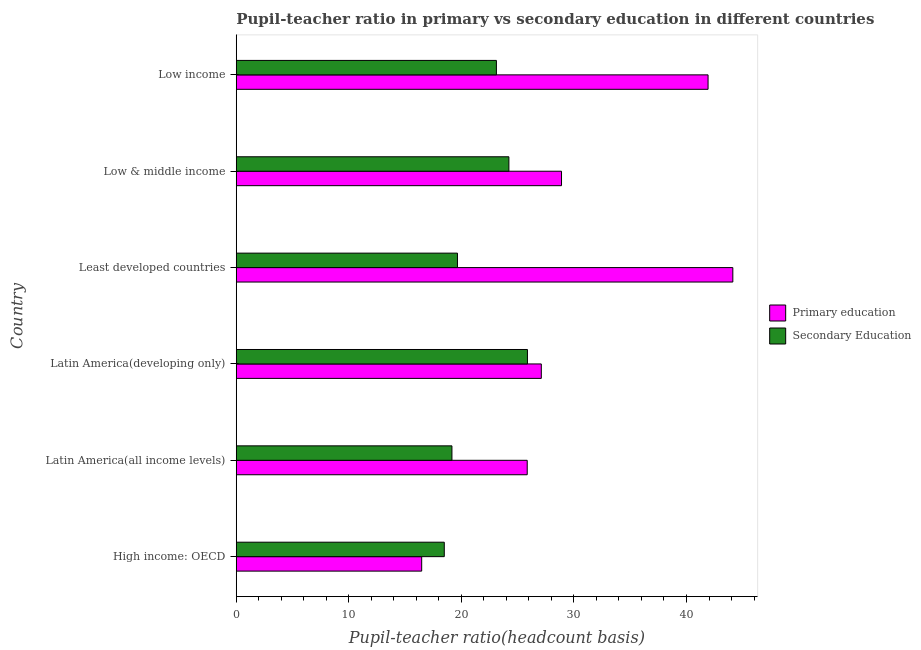How many different coloured bars are there?
Your answer should be very brief. 2. How many groups of bars are there?
Give a very brief answer. 6. Are the number of bars on each tick of the Y-axis equal?
Provide a short and direct response. Yes. How many bars are there on the 3rd tick from the top?
Keep it short and to the point. 2. What is the label of the 1st group of bars from the top?
Make the answer very short. Low income. What is the pupil teacher ratio on secondary education in Latin America(all income levels)?
Give a very brief answer. 19.16. Across all countries, what is the maximum pupil teacher ratio on secondary education?
Give a very brief answer. 25.87. Across all countries, what is the minimum pupil-teacher ratio in primary education?
Offer a very short reply. 16.47. In which country was the pupil teacher ratio on secondary education maximum?
Provide a succinct answer. Latin America(developing only). In which country was the pupil teacher ratio on secondary education minimum?
Provide a succinct answer. High income: OECD. What is the total pupil teacher ratio on secondary education in the graph?
Give a very brief answer. 130.5. What is the difference between the pupil teacher ratio on secondary education in Latin America(all income levels) and that in Low & middle income?
Your response must be concise. -5.06. What is the difference between the pupil teacher ratio on secondary education in High income: OECD and the pupil-teacher ratio in primary education in Low income?
Make the answer very short. -23.44. What is the average pupil-teacher ratio in primary education per country?
Provide a short and direct response. 30.73. What is the difference between the pupil-teacher ratio in primary education and pupil teacher ratio on secondary education in High income: OECD?
Offer a very short reply. -2.01. In how many countries, is the pupil teacher ratio on secondary education greater than 12 ?
Offer a terse response. 6. What is the ratio of the pupil teacher ratio on secondary education in Latin America(all income levels) to that in Low income?
Your answer should be very brief. 0.83. What is the difference between the highest and the second highest pupil teacher ratio on secondary education?
Give a very brief answer. 1.65. What is the difference between the highest and the lowest pupil-teacher ratio in primary education?
Ensure brevity in your answer.  27.64. How many bars are there?
Offer a very short reply. 12. What is the difference between two consecutive major ticks on the X-axis?
Ensure brevity in your answer.  10. Are the values on the major ticks of X-axis written in scientific E-notation?
Give a very brief answer. No. Does the graph contain any zero values?
Your answer should be compact. No. Where does the legend appear in the graph?
Provide a short and direct response. Center right. How are the legend labels stacked?
Give a very brief answer. Vertical. What is the title of the graph?
Provide a short and direct response. Pupil-teacher ratio in primary vs secondary education in different countries. Does "Official creditors" appear as one of the legend labels in the graph?
Your answer should be very brief. No. What is the label or title of the X-axis?
Keep it short and to the point. Pupil-teacher ratio(headcount basis). What is the label or title of the Y-axis?
Offer a very short reply. Country. What is the Pupil-teacher ratio(headcount basis) in Primary education in High income: OECD?
Ensure brevity in your answer.  16.47. What is the Pupil-teacher ratio(headcount basis) in Secondary Education in High income: OECD?
Your response must be concise. 18.48. What is the Pupil-teacher ratio(headcount basis) of Primary education in Latin America(all income levels)?
Your answer should be very brief. 25.85. What is the Pupil-teacher ratio(headcount basis) in Secondary Education in Latin America(all income levels)?
Provide a short and direct response. 19.16. What is the Pupil-teacher ratio(headcount basis) in Primary education in Latin America(developing only)?
Ensure brevity in your answer.  27.1. What is the Pupil-teacher ratio(headcount basis) of Secondary Education in Latin America(developing only)?
Your answer should be very brief. 25.87. What is the Pupil-teacher ratio(headcount basis) in Primary education in Least developed countries?
Your answer should be very brief. 44.12. What is the Pupil-teacher ratio(headcount basis) in Secondary Education in Least developed countries?
Your answer should be compact. 19.65. What is the Pupil-teacher ratio(headcount basis) of Primary education in Low & middle income?
Provide a succinct answer. 28.9. What is the Pupil-teacher ratio(headcount basis) of Secondary Education in Low & middle income?
Give a very brief answer. 24.22. What is the Pupil-teacher ratio(headcount basis) of Primary education in Low income?
Your response must be concise. 41.92. What is the Pupil-teacher ratio(headcount basis) of Secondary Education in Low income?
Offer a terse response. 23.11. Across all countries, what is the maximum Pupil-teacher ratio(headcount basis) in Primary education?
Give a very brief answer. 44.12. Across all countries, what is the maximum Pupil-teacher ratio(headcount basis) of Secondary Education?
Your answer should be very brief. 25.87. Across all countries, what is the minimum Pupil-teacher ratio(headcount basis) in Primary education?
Your answer should be very brief. 16.47. Across all countries, what is the minimum Pupil-teacher ratio(headcount basis) in Secondary Education?
Your response must be concise. 18.48. What is the total Pupil-teacher ratio(headcount basis) in Primary education in the graph?
Offer a terse response. 184.36. What is the total Pupil-teacher ratio(headcount basis) in Secondary Education in the graph?
Ensure brevity in your answer.  130.5. What is the difference between the Pupil-teacher ratio(headcount basis) in Primary education in High income: OECD and that in Latin America(all income levels)?
Give a very brief answer. -9.38. What is the difference between the Pupil-teacher ratio(headcount basis) of Secondary Education in High income: OECD and that in Latin America(all income levels)?
Offer a very short reply. -0.68. What is the difference between the Pupil-teacher ratio(headcount basis) of Primary education in High income: OECD and that in Latin America(developing only)?
Give a very brief answer. -10.63. What is the difference between the Pupil-teacher ratio(headcount basis) of Secondary Education in High income: OECD and that in Latin America(developing only)?
Offer a very short reply. -7.39. What is the difference between the Pupil-teacher ratio(headcount basis) of Primary education in High income: OECD and that in Least developed countries?
Your answer should be compact. -27.64. What is the difference between the Pupil-teacher ratio(headcount basis) in Secondary Education in High income: OECD and that in Least developed countries?
Give a very brief answer. -1.17. What is the difference between the Pupil-teacher ratio(headcount basis) in Primary education in High income: OECD and that in Low & middle income?
Offer a terse response. -12.42. What is the difference between the Pupil-teacher ratio(headcount basis) of Secondary Education in High income: OECD and that in Low & middle income?
Provide a short and direct response. -5.74. What is the difference between the Pupil-teacher ratio(headcount basis) in Primary education in High income: OECD and that in Low income?
Keep it short and to the point. -25.44. What is the difference between the Pupil-teacher ratio(headcount basis) of Secondary Education in High income: OECD and that in Low income?
Provide a short and direct response. -4.63. What is the difference between the Pupil-teacher ratio(headcount basis) in Primary education in Latin America(all income levels) and that in Latin America(developing only)?
Give a very brief answer. -1.25. What is the difference between the Pupil-teacher ratio(headcount basis) in Secondary Education in Latin America(all income levels) and that in Latin America(developing only)?
Your answer should be very brief. -6.71. What is the difference between the Pupil-teacher ratio(headcount basis) in Primary education in Latin America(all income levels) and that in Least developed countries?
Keep it short and to the point. -18.27. What is the difference between the Pupil-teacher ratio(headcount basis) in Secondary Education in Latin America(all income levels) and that in Least developed countries?
Make the answer very short. -0.49. What is the difference between the Pupil-teacher ratio(headcount basis) in Primary education in Latin America(all income levels) and that in Low & middle income?
Provide a succinct answer. -3.05. What is the difference between the Pupil-teacher ratio(headcount basis) of Secondary Education in Latin America(all income levels) and that in Low & middle income?
Offer a very short reply. -5.06. What is the difference between the Pupil-teacher ratio(headcount basis) in Primary education in Latin America(all income levels) and that in Low income?
Ensure brevity in your answer.  -16.07. What is the difference between the Pupil-teacher ratio(headcount basis) of Secondary Education in Latin America(all income levels) and that in Low income?
Give a very brief answer. -3.95. What is the difference between the Pupil-teacher ratio(headcount basis) in Primary education in Latin America(developing only) and that in Least developed countries?
Your answer should be compact. -17.02. What is the difference between the Pupil-teacher ratio(headcount basis) in Secondary Education in Latin America(developing only) and that in Least developed countries?
Provide a succinct answer. 6.22. What is the difference between the Pupil-teacher ratio(headcount basis) of Primary education in Latin America(developing only) and that in Low & middle income?
Offer a very short reply. -1.79. What is the difference between the Pupil-teacher ratio(headcount basis) of Secondary Education in Latin America(developing only) and that in Low & middle income?
Provide a succinct answer. 1.65. What is the difference between the Pupil-teacher ratio(headcount basis) in Primary education in Latin America(developing only) and that in Low income?
Your answer should be very brief. -14.81. What is the difference between the Pupil-teacher ratio(headcount basis) in Secondary Education in Latin America(developing only) and that in Low income?
Your response must be concise. 2.76. What is the difference between the Pupil-teacher ratio(headcount basis) in Primary education in Least developed countries and that in Low & middle income?
Make the answer very short. 15.22. What is the difference between the Pupil-teacher ratio(headcount basis) in Secondary Education in Least developed countries and that in Low & middle income?
Your response must be concise. -4.57. What is the difference between the Pupil-teacher ratio(headcount basis) in Primary education in Least developed countries and that in Low income?
Ensure brevity in your answer.  2.2. What is the difference between the Pupil-teacher ratio(headcount basis) in Secondary Education in Least developed countries and that in Low income?
Offer a terse response. -3.46. What is the difference between the Pupil-teacher ratio(headcount basis) of Primary education in Low & middle income and that in Low income?
Provide a succinct answer. -13.02. What is the difference between the Pupil-teacher ratio(headcount basis) in Secondary Education in Low & middle income and that in Low income?
Make the answer very short. 1.11. What is the difference between the Pupil-teacher ratio(headcount basis) in Primary education in High income: OECD and the Pupil-teacher ratio(headcount basis) in Secondary Education in Latin America(all income levels)?
Your answer should be compact. -2.69. What is the difference between the Pupil-teacher ratio(headcount basis) of Primary education in High income: OECD and the Pupil-teacher ratio(headcount basis) of Secondary Education in Latin America(developing only)?
Give a very brief answer. -9.4. What is the difference between the Pupil-teacher ratio(headcount basis) of Primary education in High income: OECD and the Pupil-teacher ratio(headcount basis) of Secondary Education in Least developed countries?
Make the answer very short. -3.18. What is the difference between the Pupil-teacher ratio(headcount basis) of Primary education in High income: OECD and the Pupil-teacher ratio(headcount basis) of Secondary Education in Low & middle income?
Your response must be concise. -7.75. What is the difference between the Pupil-teacher ratio(headcount basis) in Primary education in High income: OECD and the Pupil-teacher ratio(headcount basis) in Secondary Education in Low income?
Keep it short and to the point. -6.64. What is the difference between the Pupil-teacher ratio(headcount basis) in Primary education in Latin America(all income levels) and the Pupil-teacher ratio(headcount basis) in Secondary Education in Latin America(developing only)?
Ensure brevity in your answer.  -0.02. What is the difference between the Pupil-teacher ratio(headcount basis) in Primary education in Latin America(all income levels) and the Pupil-teacher ratio(headcount basis) in Secondary Education in Least developed countries?
Your response must be concise. 6.2. What is the difference between the Pupil-teacher ratio(headcount basis) of Primary education in Latin America(all income levels) and the Pupil-teacher ratio(headcount basis) of Secondary Education in Low & middle income?
Provide a succinct answer. 1.63. What is the difference between the Pupil-teacher ratio(headcount basis) of Primary education in Latin America(all income levels) and the Pupil-teacher ratio(headcount basis) of Secondary Education in Low income?
Provide a short and direct response. 2.74. What is the difference between the Pupil-teacher ratio(headcount basis) in Primary education in Latin America(developing only) and the Pupil-teacher ratio(headcount basis) in Secondary Education in Least developed countries?
Keep it short and to the point. 7.45. What is the difference between the Pupil-teacher ratio(headcount basis) of Primary education in Latin America(developing only) and the Pupil-teacher ratio(headcount basis) of Secondary Education in Low & middle income?
Keep it short and to the point. 2.88. What is the difference between the Pupil-teacher ratio(headcount basis) of Primary education in Latin America(developing only) and the Pupil-teacher ratio(headcount basis) of Secondary Education in Low income?
Offer a very short reply. 3.99. What is the difference between the Pupil-teacher ratio(headcount basis) in Primary education in Least developed countries and the Pupil-teacher ratio(headcount basis) in Secondary Education in Low & middle income?
Keep it short and to the point. 19.9. What is the difference between the Pupil-teacher ratio(headcount basis) of Primary education in Least developed countries and the Pupil-teacher ratio(headcount basis) of Secondary Education in Low income?
Offer a terse response. 21.01. What is the difference between the Pupil-teacher ratio(headcount basis) of Primary education in Low & middle income and the Pupil-teacher ratio(headcount basis) of Secondary Education in Low income?
Your response must be concise. 5.78. What is the average Pupil-teacher ratio(headcount basis) of Primary education per country?
Make the answer very short. 30.73. What is the average Pupil-teacher ratio(headcount basis) in Secondary Education per country?
Provide a short and direct response. 21.75. What is the difference between the Pupil-teacher ratio(headcount basis) of Primary education and Pupil-teacher ratio(headcount basis) of Secondary Education in High income: OECD?
Provide a succinct answer. -2.01. What is the difference between the Pupil-teacher ratio(headcount basis) in Primary education and Pupil-teacher ratio(headcount basis) in Secondary Education in Latin America(all income levels)?
Your answer should be very brief. 6.69. What is the difference between the Pupil-teacher ratio(headcount basis) in Primary education and Pupil-teacher ratio(headcount basis) in Secondary Education in Latin America(developing only)?
Make the answer very short. 1.23. What is the difference between the Pupil-teacher ratio(headcount basis) in Primary education and Pupil-teacher ratio(headcount basis) in Secondary Education in Least developed countries?
Keep it short and to the point. 24.46. What is the difference between the Pupil-teacher ratio(headcount basis) in Primary education and Pupil-teacher ratio(headcount basis) in Secondary Education in Low & middle income?
Offer a very short reply. 4.68. What is the difference between the Pupil-teacher ratio(headcount basis) of Primary education and Pupil-teacher ratio(headcount basis) of Secondary Education in Low income?
Your answer should be very brief. 18.8. What is the ratio of the Pupil-teacher ratio(headcount basis) in Primary education in High income: OECD to that in Latin America(all income levels)?
Your response must be concise. 0.64. What is the ratio of the Pupil-teacher ratio(headcount basis) of Secondary Education in High income: OECD to that in Latin America(all income levels)?
Your answer should be compact. 0.96. What is the ratio of the Pupil-teacher ratio(headcount basis) of Primary education in High income: OECD to that in Latin America(developing only)?
Offer a terse response. 0.61. What is the ratio of the Pupil-teacher ratio(headcount basis) of Secondary Education in High income: OECD to that in Latin America(developing only)?
Make the answer very short. 0.71. What is the ratio of the Pupil-teacher ratio(headcount basis) in Primary education in High income: OECD to that in Least developed countries?
Ensure brevity in your answer.  0.37. What is the ratio of the Pupil-teacher ratio(headcount basis) in Secondary Education in High income: OECD to that in Least developed countries?
Keep it short and to the point. 0.94. What is the ratio of the Pupil-teacher ratio(headcount basis) of Primary education in High income: OECD to that in Low & middle income?
Make the answer very short. 0.57. What is the ratio of the Pupil-teacher ratio(headcount basis) of Secondary Education in High income: OECD to that in Low & middle income?
Offer a very short reply. 0.76. What is the ratio of the Pupil-teacher ratio(headcount basis) of Primary education in High income: OECD to that in Low income?
Your answer should be compact. 0.39. What is the ratio of the Pupil-teacher ratio(headcount basis) in Secondary Education in High income: OECD to that in Low income?
Offer a terse response. 0.8. What is the ratio of the Pupil-teacher ratio(headcount basis) of Primary education in Latin America(all income levels) to that in Latin America(developing only)?
Your answer should be compact. 0.95. What is the ratio of the Pupil-teacher ratio(headcount basis) in Secondary Education in Latin America(all income levels) to that in Latin America(developing only)?
Give a very brief answer. 0.74. What is the ratio of the Pupil-teacher ratio(headcount basis) of Primary education in Latin America(all income levels) to that in Least developed countries?
Provide a succinct answer. 0.59. What is the ratio of the Pupil-teacher ratio(headcount basis) of Primary education in Latin America(all income levels) to that in Low & middle income?
Offer a very short reply. 0.89. What is the ratio of the Pupil-teacher ratio(headcount basis) of Secondary Education in Latin America(all income levels) to that in Low & middle income?
Provide a short and direct response. 0.79. What is the ratio of the Pupil-teacher ratio(headcount basis) in Primary education in Latin America(all income levels) to that in Low income?
Offer a terse response. 0.62. What is the ratio of the Pupil-teacher ratio(headcount basis) of Secondary Education in Latin America(all income levels) to that in Low income?
Your answer should be compact. 0.83. What is the ratio of the Pupil-teacher ratio(headcount basis) of Primary education in Latin America(developing only) to that in Least developed countries?
Offer a very short reply. 0.61. What is the ratio of the Pupil-teacher ratio(headcount basis) of Secondary Education in Latin America(developing only) to that in Least developed countries?
Provide a short and direct response. 1.32. What is the ratio of the Pupil-teacher ratio(headcount basis) of Primary education in Latin America(developing only) to that in Low & middle income?
Keep it short and to the point. 0.94. What is the ratio of the Pupil-teacher ratio(headcount basis) of Secondary Education in Latin America(developing only) to that in Low & middle income?
Provide a short and direct response. 1.07. What is the ratio of the Pupil-teacher ratio(headcount basis) in Primary education in Latin America(developing only) to that in Low income?
Keep it short and to the point. 0.65. What is the ratio of the Pupil-teacher ratio(headcount basis) in Secondary Education in Latin America(developing only) to that in Low income?
Keep it short and to the point. 1.12. What is the ratio of the Pupil-teacher ratio(headcount basis) in Primary education in Least developed countries to that in Low & middle income?
Keep it short and to the point. 1.53. What is the ratio of the Pupil-teacher ratio(headcount basis) of Secondary Education in Least developed countries to that in Low & middle income?
Ensure brevity in your answer.  0.81. What is the ratio of the Pupil-teacher ratio(headcount basis) in Primary education in Least developed countries to that in Low income?
Provide a succinct answer. 1.05. What is the ratio of the Pupil-teacher ratio(headcount basis) in Secondary Education in Least developed countries to that in Low income?
Give a very brief answer. 0.85. What is the ratio of the Pupil-teacher ratio(headcount basis) of Primary education in Low & middle income to that in Low income?
Provide a succinct answer. 0.69. What is the ratio of the Pupil-teacher ratio(headcount basis) in Secondary Education in Low & middle income to that in Low income?
Give a very brief answer. 1.05. What is the difference between the highest and the second highest Pupil-teacher ratio(headcount basis) of Primary education?
Make the answer very short. 2.2. What is the difference between the highest and the second highest Pupil-teacher ratio(headcount basis) in Secondary Education?
Keep it short and to the point. 1.65. What is the difference between the highest and the lowest Pupil-teacher ratio(headcount basis) of Primary education?
Your answer should be very brief. 27.64. What is the difference between the highest and the lowest Pupil-teacher ratio(headcount basis) in Secondary Education?
Your answer should be very brief. 7.39. 